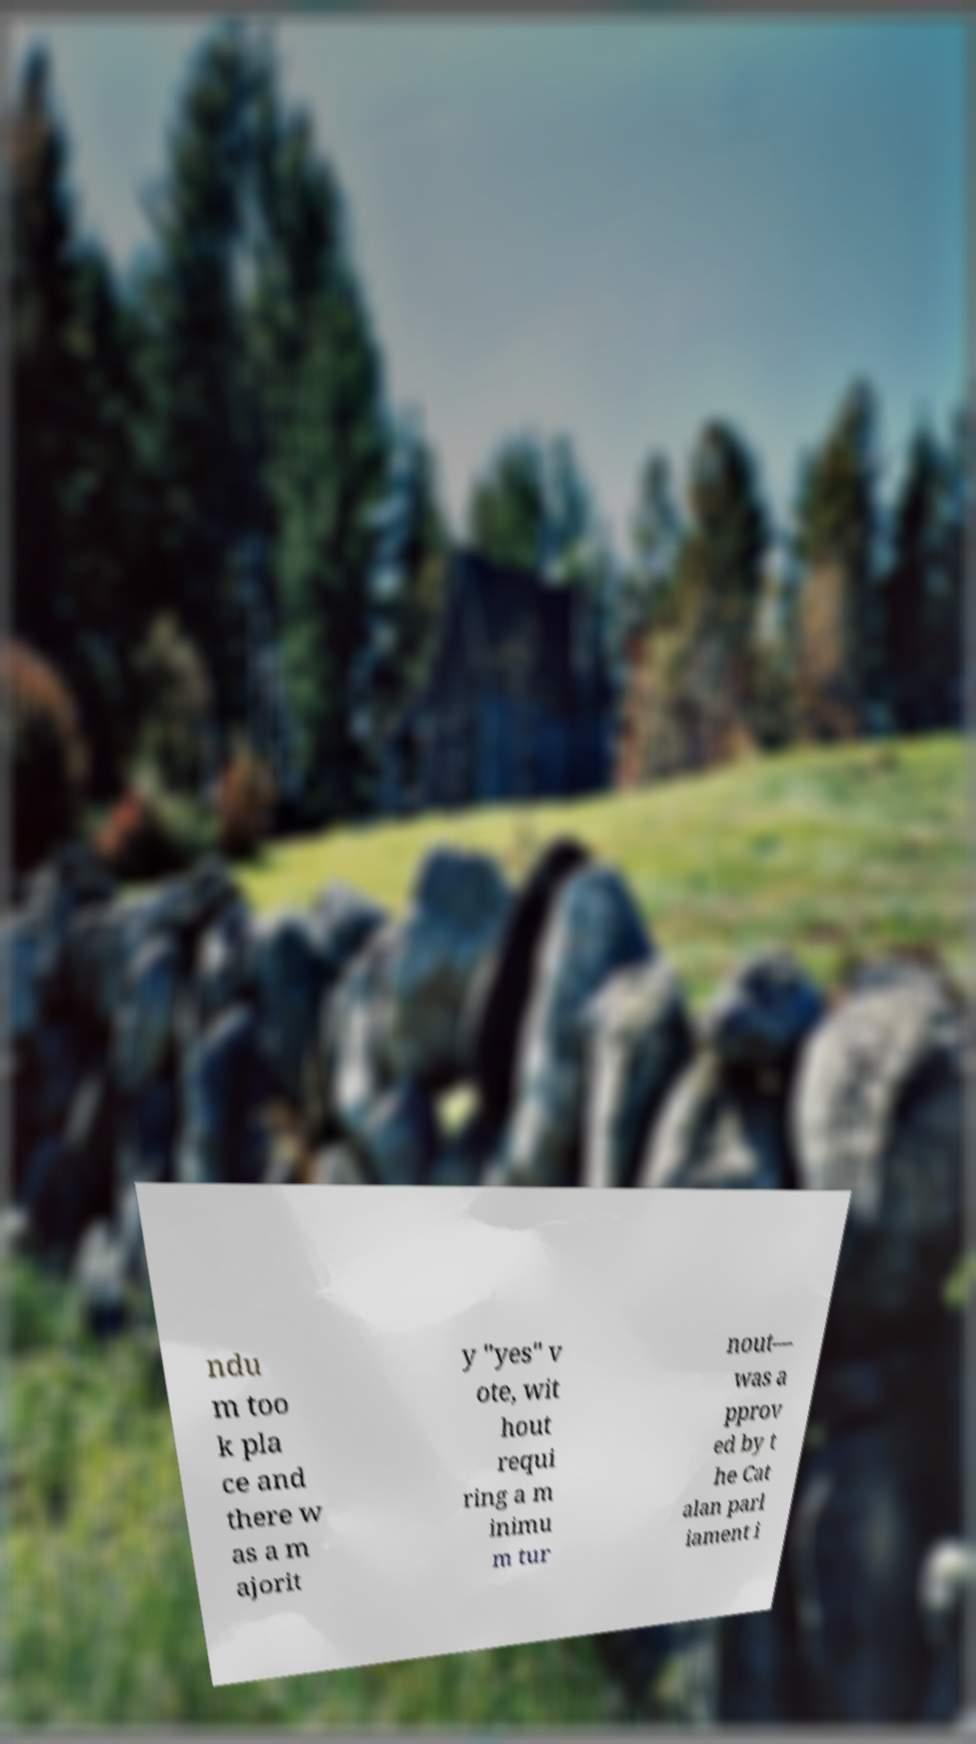Can you accurately transcribe the text from the provided image for me? ndu m too k pla ce and there w as a m ajorit y "yes" v ote, wit hout requi ring a m inimu m tur nout— was a pprov ed by t he Cat alan parl iament i 